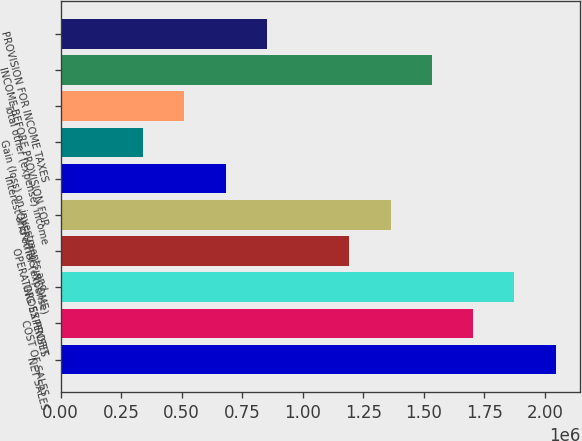<chart> <loc_0><loc_0><loc_500><loc_500><bar_chart><fcel>NET SALES<fcel>COST OF SALES<fcel>GROSS PROFIT<fcel>OPERATING EXPENSES<fcel>OPERATING INCOME<fcel>Interest and other (expense)<fcel>Gain (loss) on investments and<fcel>Total other (expense) income<fcel>INCOME BEFORE PROVISION FOR<fcel>PROVISION FOR INCOME TAXES<nl><fcel>2.04388e+06<fcel>1.70323e+06<fcel>1.87355e+06<fcel>1.19226e+06<fcel>1.36258e+06<fcel>681293<fcel>340647<fcel>510970<fcel>1.53291e+06<fcel>851616<nl></chart> 